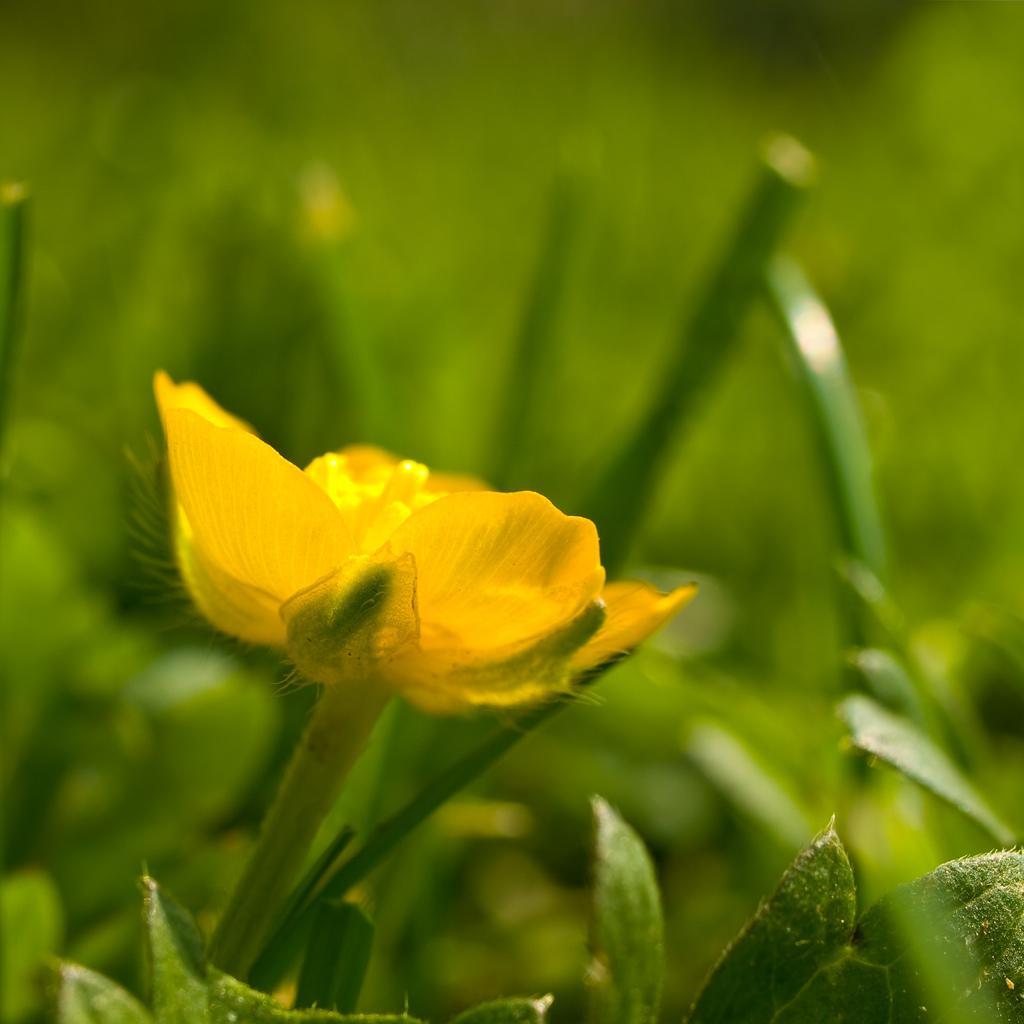Please provide a concise description of this image. In this image we can see yellow color flower in the middle of the image. Behind we can see green Leaves. 